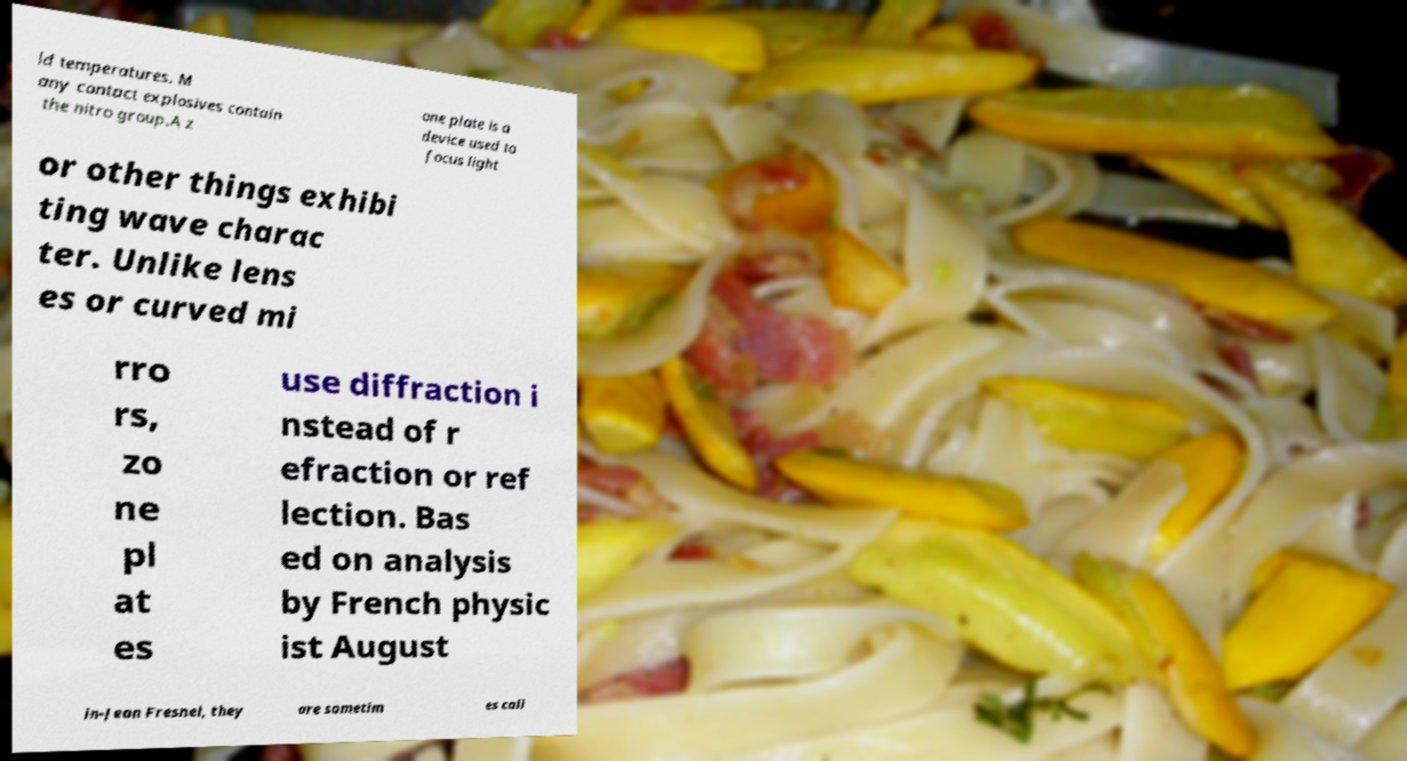Could you assist in decoding the text presented in this image and type it out clearly? ld temperatures. M any contact explosives contain the nitro group.A z one plate is a device used to focus light or other things exhibi ting wave charac ter. Unlike lens es or curved mi rro rs, zo ne pl at es use diffraction i nstead of r efraction or ref lection. Bas ed on analysis by French physic ist August in-Jean Fresnel, they are sometim es call 